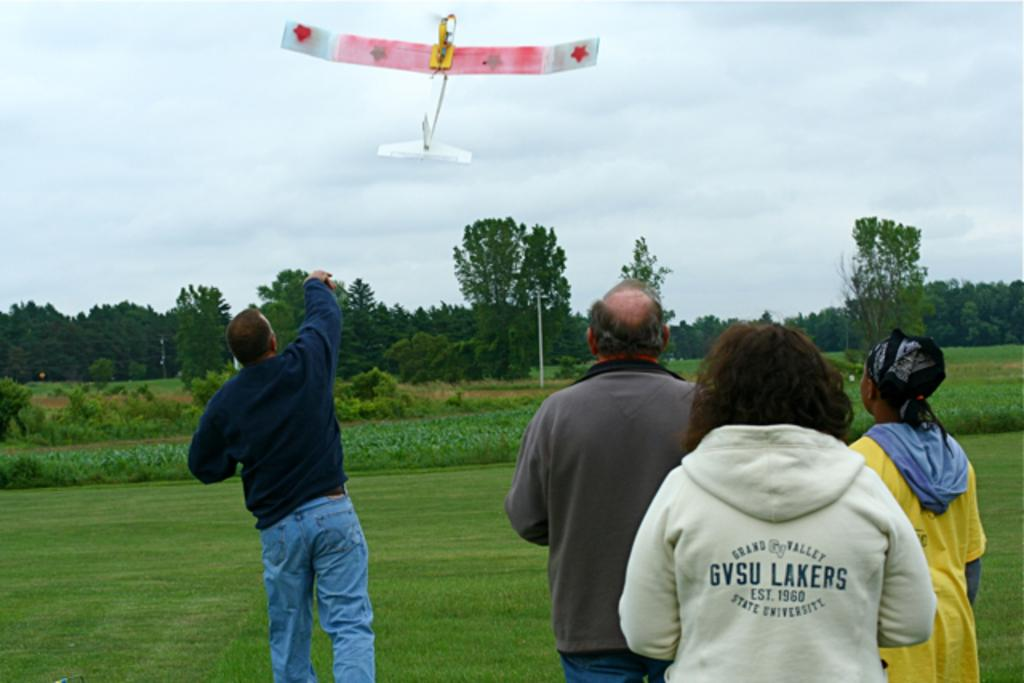Provide a one-sentence caption for the provided image. One of the people watching a man launch a model airplane by throwing it into the air is wearing a jacket from Grand Valley University. 